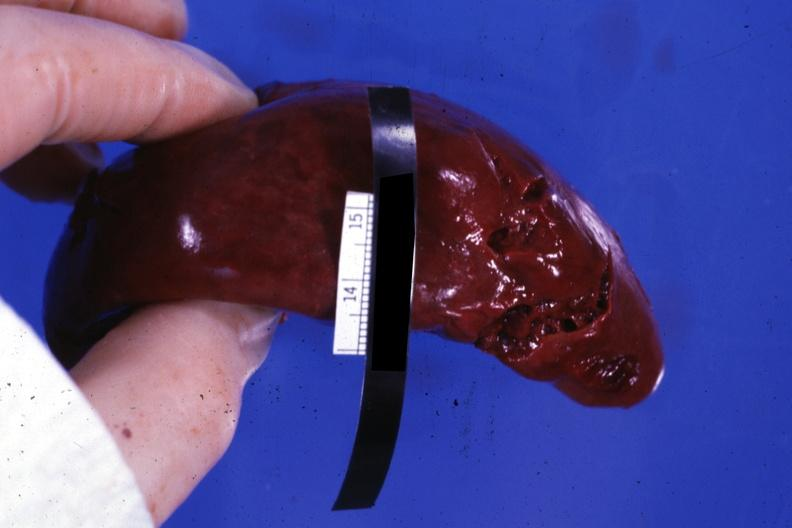what is present?
Answer the question using a single word or phrase. Laceration 